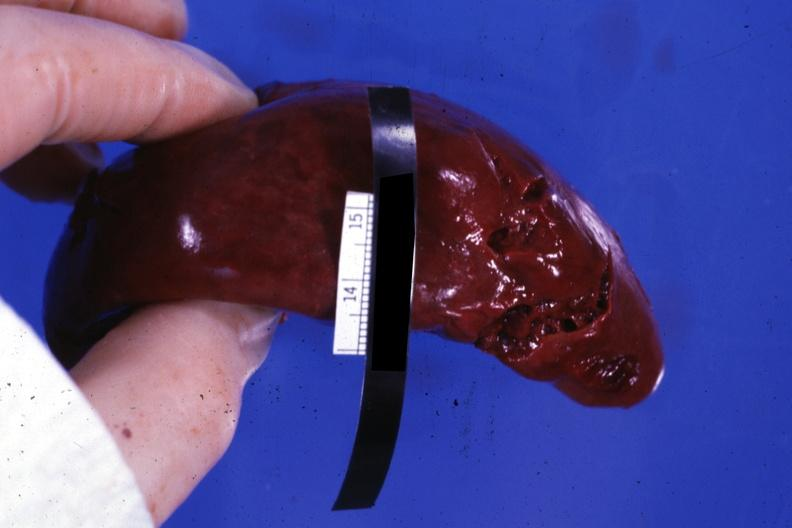what is present?
Answer the question using a single word or phrase. Laceration 